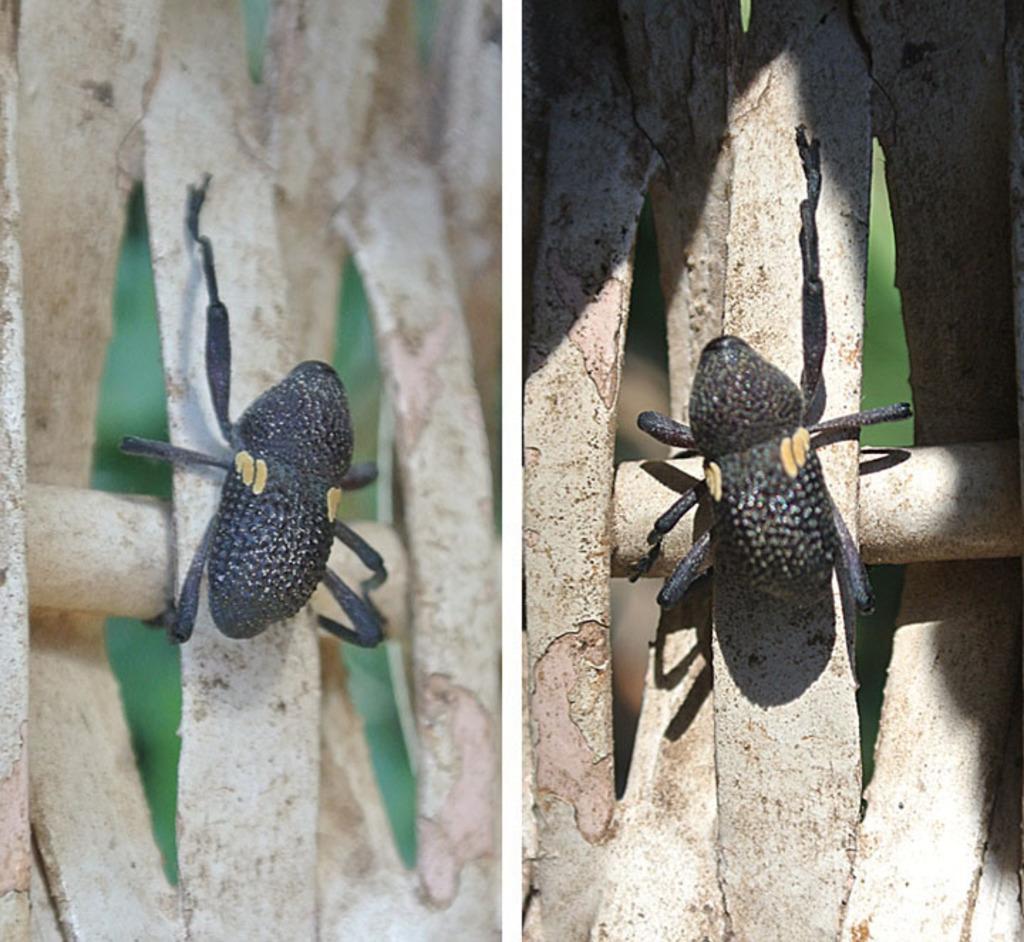In one or two sentences, can you explain what this image depicts? This picture is collage of two images in which there are insects on the branch of a tree. 